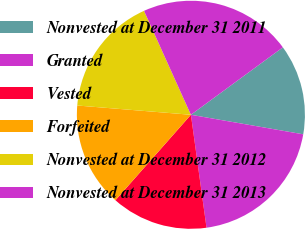Convert chart. <chart><loc_0><loc_0><loc_500><loc_500><pie_chart><fcel>Nonvested at December 31 2011<fcel>Granted<fcel>Vested<fcel>Forfeited<fcel>Nonvested at December 31 2012<fcel>Nonvested at December 31 2013<nl><fcel>12.81%<fcel>20.07%<fcel>13.7%<fcel>14.78%<fcel>16.96%<fcel>21.67%<nl></chart> 